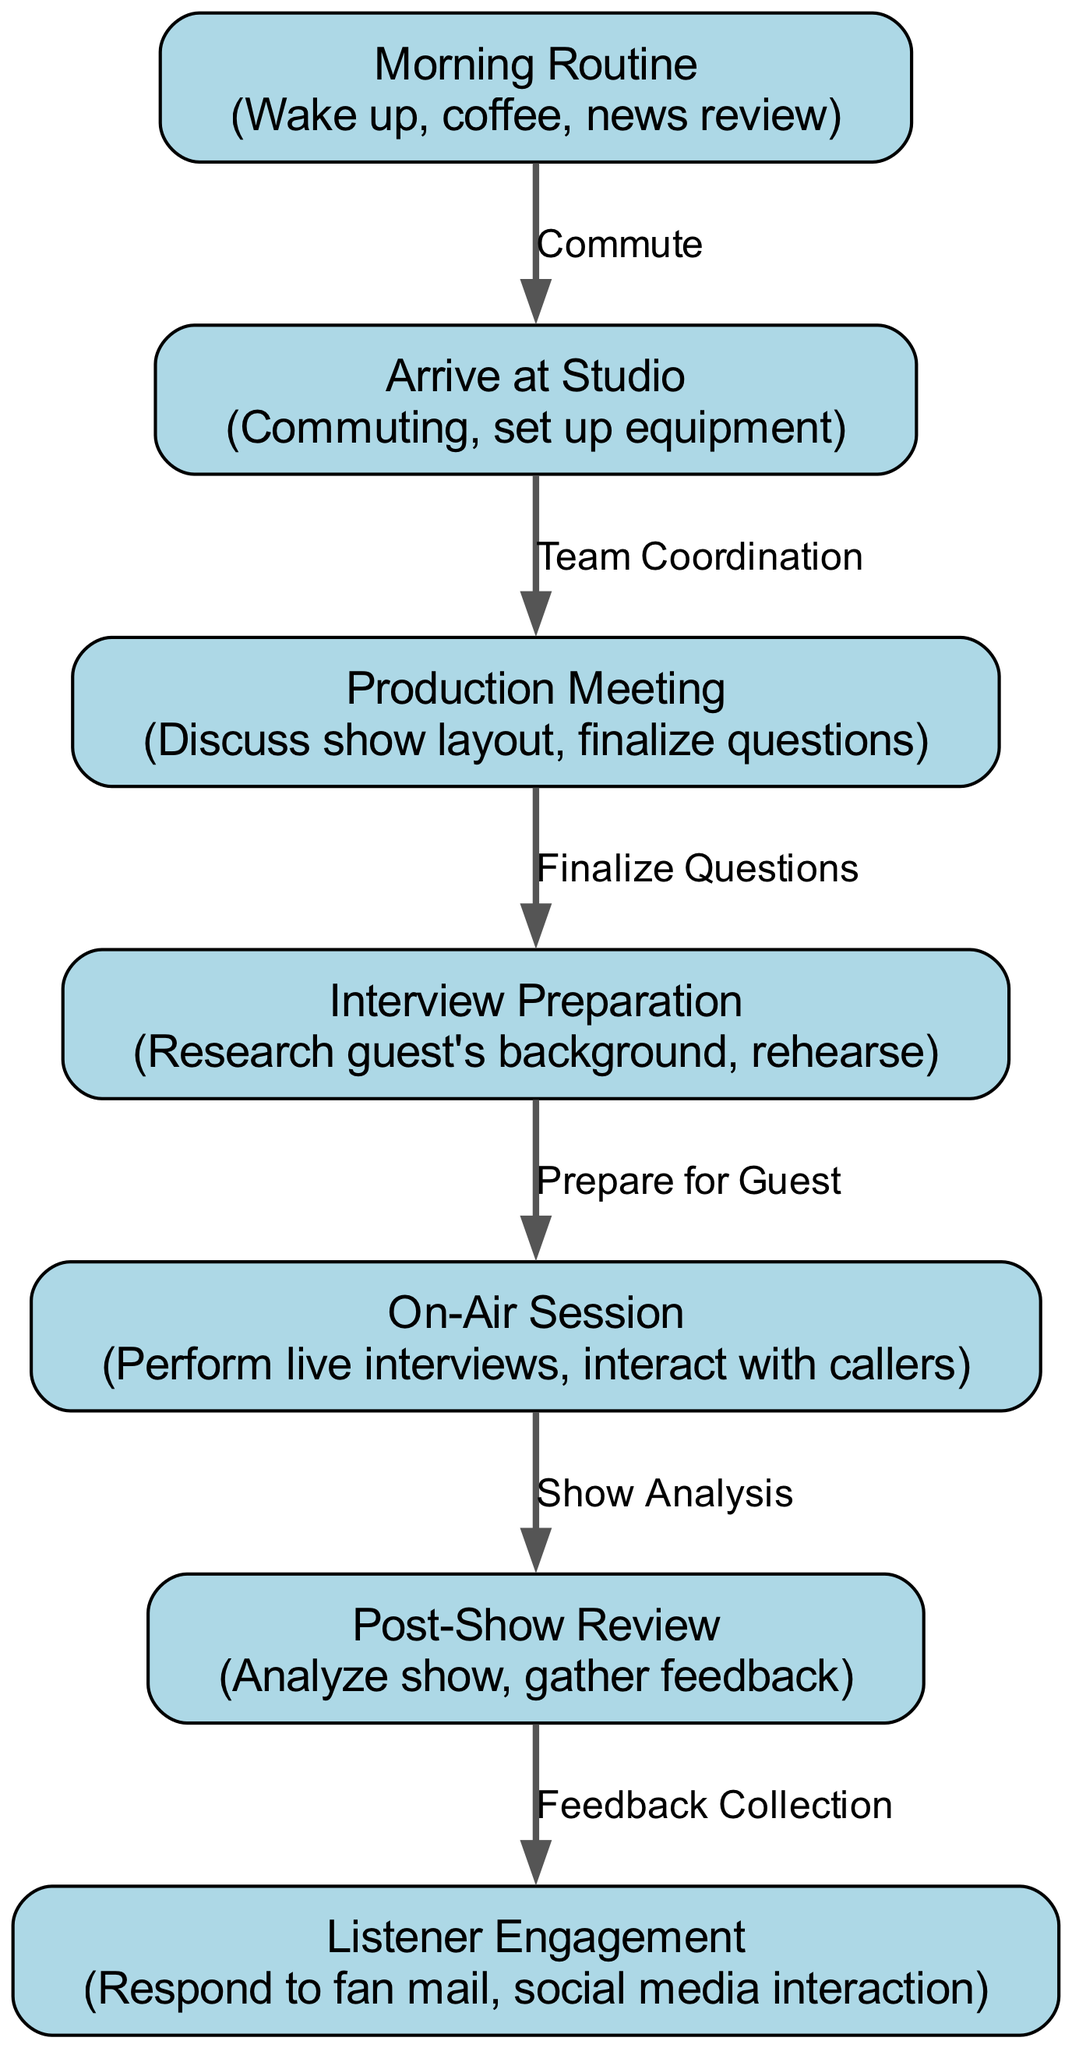What's the first step in the daily schedule? The first node in the diagram is "Morning Routine," indicating it is the start of the daily activities for the radio host.
Answer: Morning Routine How many nodes are present in the diagram? By counting the individual nodes listed, there are a total of 7 nodes depicted in the diagram.
Answer: 7 What follows after the "Production Meeting"? The "Interview Preparation" node directly follows the "Production Meeting", indicated by the connecting edge labeled "Finalize Questions."
Answer: Interview Preparation What is the last activity in the daily schedule? The final node in the schedule is "Listener Engagement," which is connected to the preceding node "Post-Show Review."
Answer: Listener Engagement What is the connection type between "Studio Arrival" and "Production Meeting"? The edge connecting these two nodes is labeled "Team Coordination," which describes their relationship in the schedule.
Answer: Team Coordination Which activity involves live interactions? The node labeled "On-Air Session" describes live interviews and interactions with callers, making it the activity focused on live interactions.
Answer: On-Air Session Explain the flow from "On-Air Session" to "Post-Show Review." The diagram indicates that after the "On-Air Session," the next step is the "Post-Show Review," connected by an edge that suggests evaluating the show's performance.
Answer: Post-Show Review What task is completed before "On-Air Session"? The "Interview Preparation" node is the last task before the "On-Air Session," ensuring that the host is ready for interviewing guests.
Answer: Interview Preparation What activity involves feedback collection? The "Listener Engagement" node focuses on gathering feedback from listeners, linked by an edge from "Post-Show Review," which showcases the collection process.
Answer: Listener Engagement 